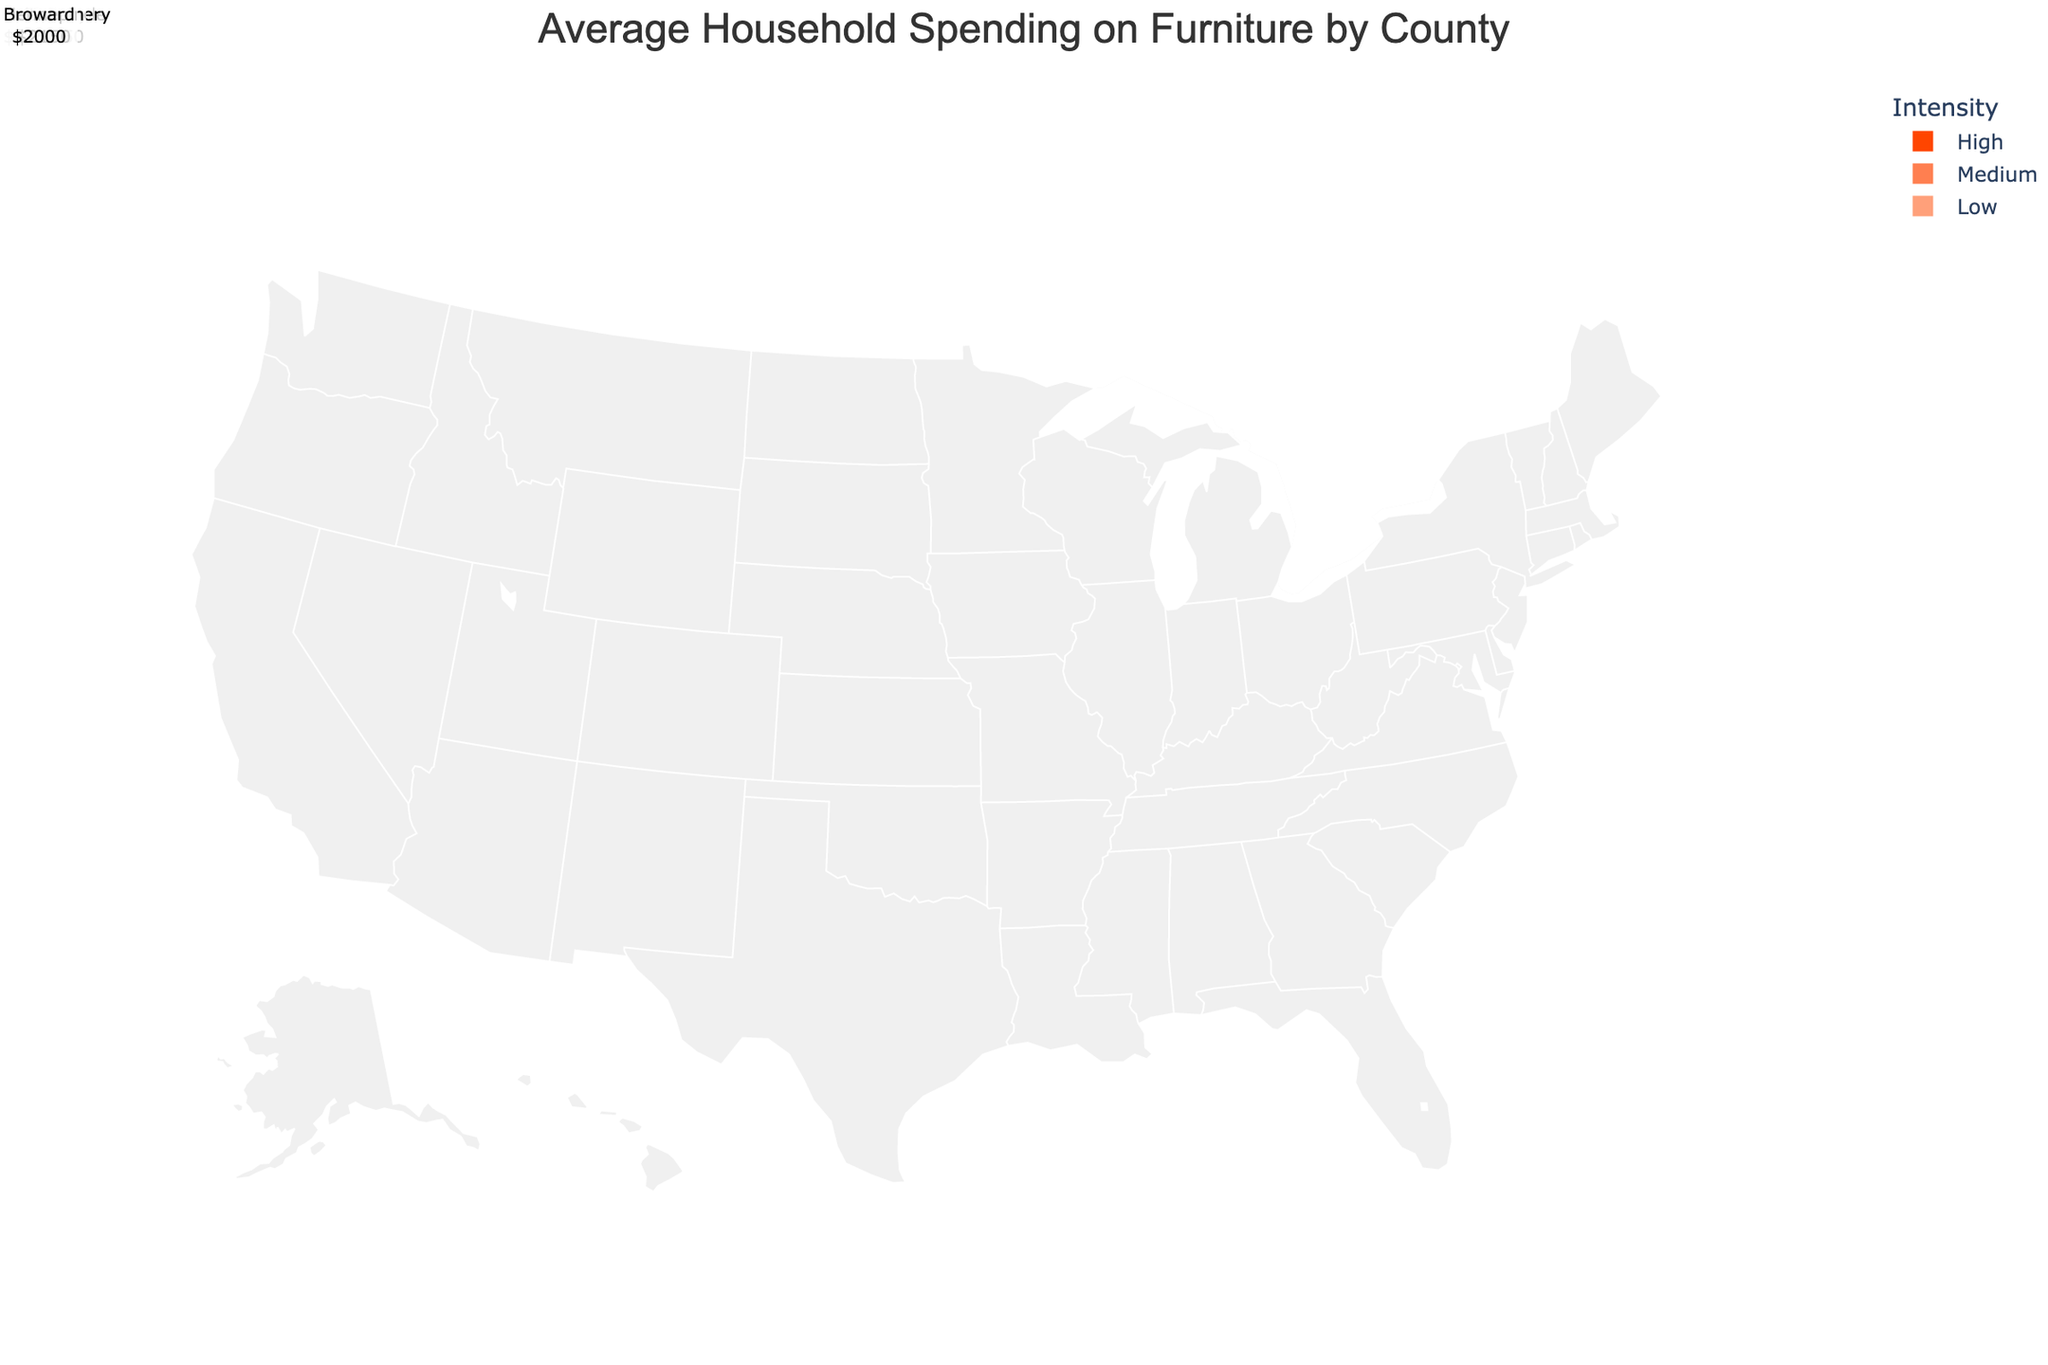What's the title of the figure? The title is usually found at the top of the figure and is a summary of what the figure represents.
Answer: Average Household Spending on Furniture by County What do the different colors represent on the map? The color intensity on the map corresponds to the level of average household spending, with 'Low' typically being a lighter shade, 'Medium' being a middle shade, and 'High' being a darker shade.
Answer: Levels of average household spending Which county has the highest average household spending on furniture? By looking at the darkest shades on the map, we can identify the counties with the 'High' spending intensity and compare their values.
Answer: Fairfax, Virginia How many counties have 'High' spending intensity? By observing the number of counties colored with the darkest shade, we can count them.
Answer: 6 What is the average household spending on furniture in Cook, Illinois? We can hover over or refer to the annotations or data points in the map to find Cook, Illinois and its spending data.
Answer: $2,100 Is the average spending on furniture higher in Dallas, Texas compared to Hennepin, Minnesota? By comparing the average spending data for Dallas and Hennepin as indicated on the map, we can determine which is higher.
Answer: Yes, Dallas has higher spending Which state has more counties with 'Medium' spending intensity: Texas or Florida? By counting the counties colored with the 'Medium' shade in each state on the map, we can compare the totals.
Answer: Texas Is there any county in the data with a 'Low' spending intensity? By checking the color intensities on the map, we can see if there are any counties shaded with the lightest color.
Answer: Yes What's the combined average spending of the counties in California? By adding the average spending amounts of Los Angeles, San Diego, and Orange counties, we obtain the combined total. Calculation: 2850 + 2600 + 2750 = 8200.
Answer: $8,200 Which county in New York state is represented on the map and what is its spending level? By referring to the annotations or data points for New York state, we can identify the county and its associated spending level.
Answer: Suffolk, Medium 